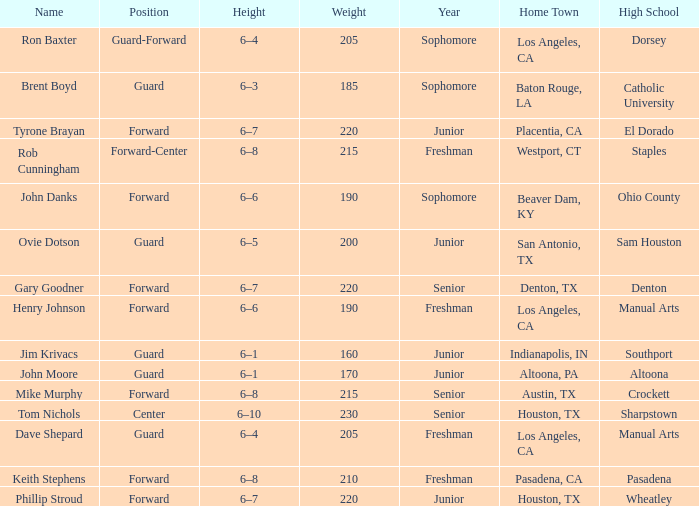What is the name of an individual with a freshman year, a home town located in los angeles, ca, and standing at a height of 6–4? Dave Shepard. 